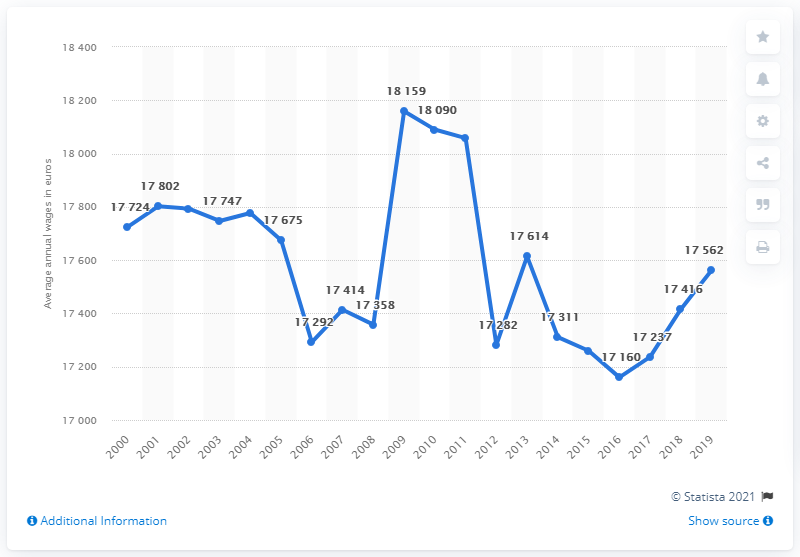Give some essential details in this illustration. What is the difference between the first and last data point?" is a question asking for an explanation or comparison between two pieces of information. The value recorded in 2013 is 17614. 